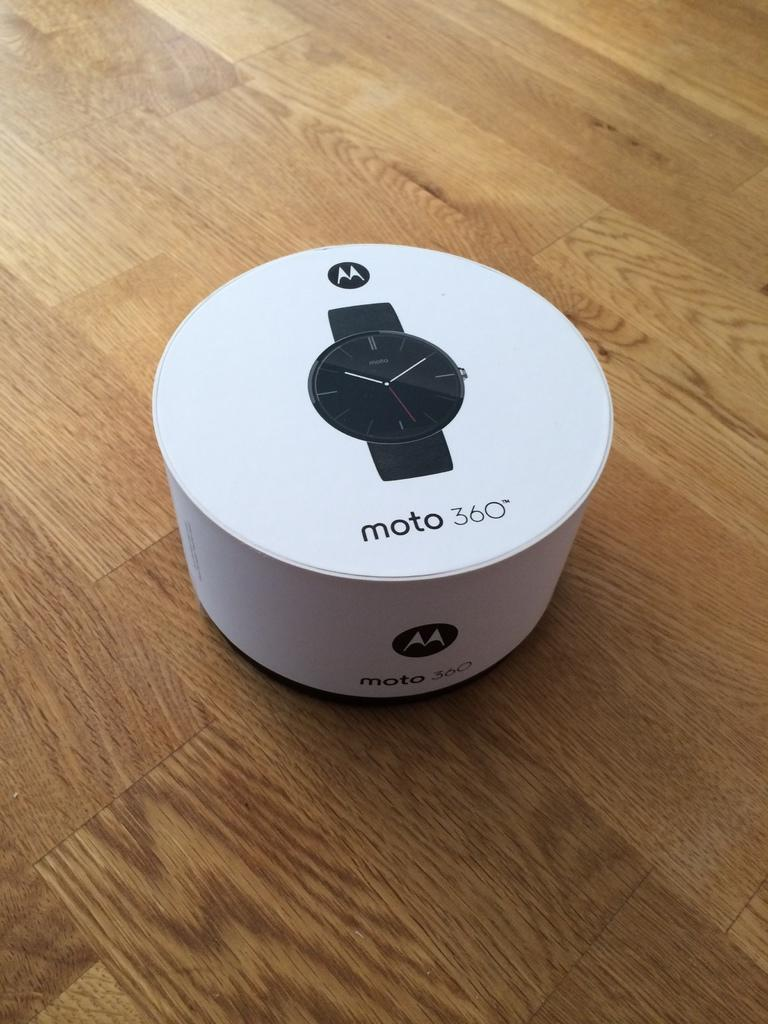Provide a one-sentence caption for the provided image. A moto 360 smart watch package is sitting on a wooden floor. 